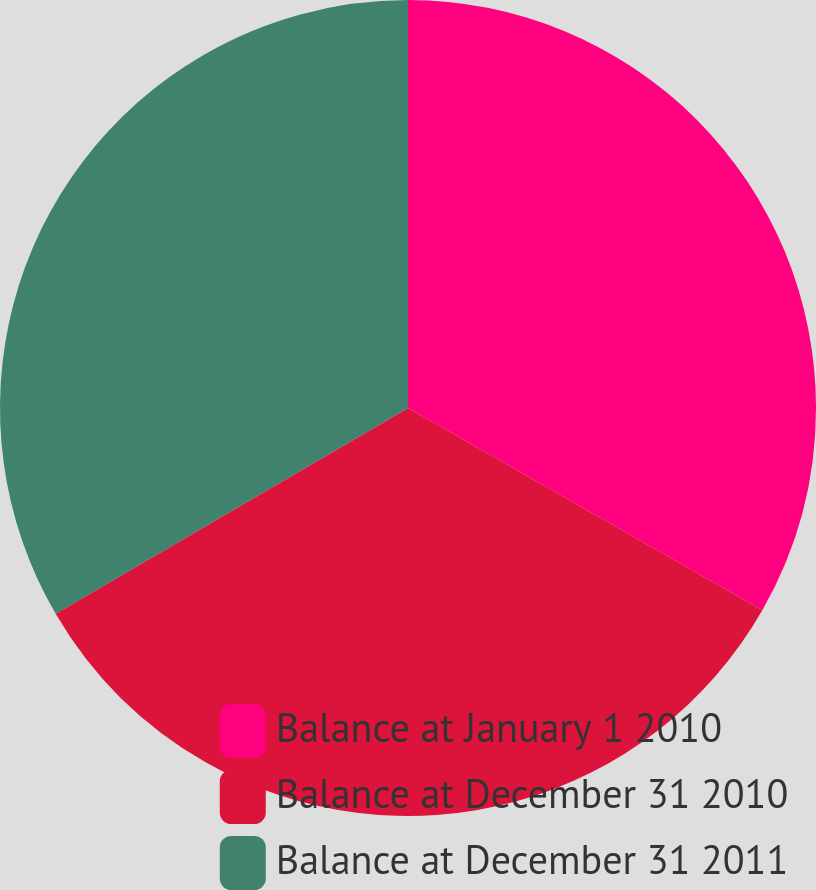Convert chart to OTSL. <chart><loc_0><loc_0><loc_500><loc_500><pie_chart><fcel>Balance at January 1 2010<fcel>Balance at December 31 2010<fcel>Balance at December 31 2011<nl><fcel>33.26%<fcel>33.33%<fcel>33.41%<nl></chart> 